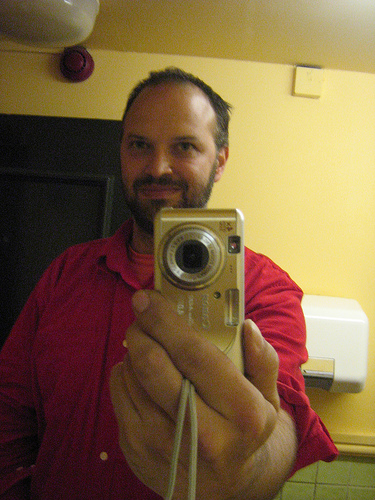<image>
Can you confirm if the man is behind the camera? Yes. From this viewpoint, the man is positioned behind the camera, with the camera partially or fully occluding the man. 